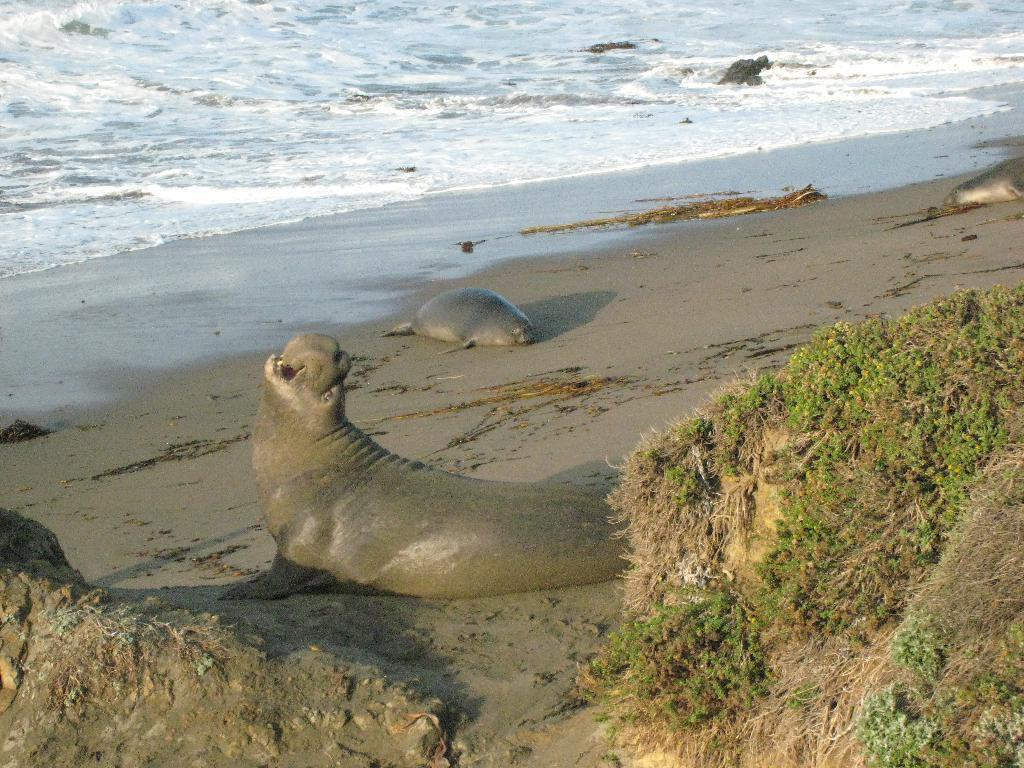Describe this image in one or two sentences. In this image there are few elephant seals on the surface of the sand. On the right side of the image there is grass. In the background there is a river. 